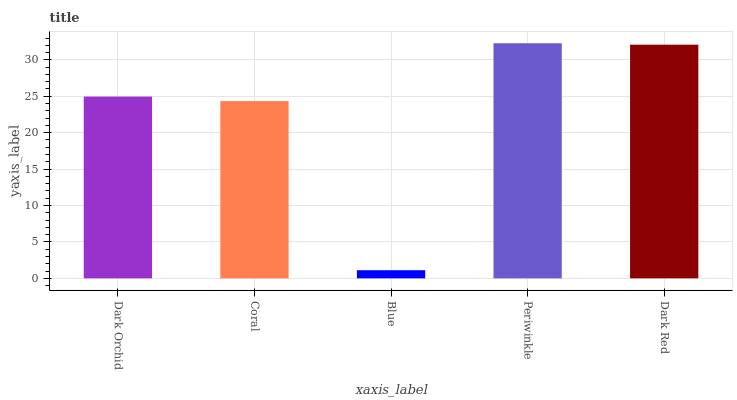Is Blue the minimum?
Answer yes or no. Yes. Is Periwinkle the maximum?
Answer yes or no. Yes. Is Coral the minimum?
Answer yes or no. No. Is Coral the maximum?
Answer yes or no. No. Is Dark Orchid greater than Coral?
Answer yes or no. Yes. Is Coral less than Dark Orchid?
Answer yes or no. Yes. Is Coral greater than Dark Orchid?
Answer yes or no. No. Is Dark Orchid less than Coral?
Answer yes or no. No. Is Dark Orchid the high median?
Answer yes or no. Yes. Is Dark Orchid the low median?
Answer yes or no. Yes. Is Periwinkle the high median?
Answer yes or no. No. Is Dark Red the low median?
Answer yes or no. No. 